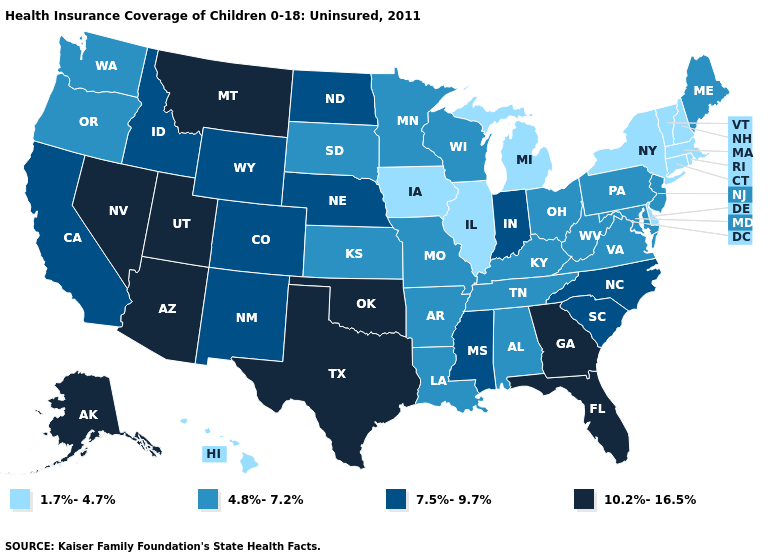Among the states that border Washington , which have the lowest value?
Write a very short answer. Oregon. Among the states that border Maryland , which have the lowest value?
Concise answer only. Delaware. How many symbols are there in the legend?
Give a very brief answer. 4. Does Texas have a higher value than Wisconsin?
Give a very brief answer. Yes. What is the value of South Carolina?
Concise answer only. 7.5%-9.7%. Among the states that border Minnesota , which have the highest value?
Quick response, please. North Dakota. What is the lowest value in the South?
Short answer required. 1.7%-4.7%. What is the lowest value in the MidWest?
Be succinct. 1.7%-4.7%. What is the highest value in the Northeast ?
Keep it brief. 4.8%-7.2%. Does the first symbol in the legend represent the smallest category?
Short answer required. Yes. Which states have the highest value in the USA?
Be succinct. Alaska, Arizona, Florida, Georgia, Montana, Nevada, Oklahoma, Texas, Utah. Does Colorado have the highest value in the West?
Answer briefly. No. How many symbols are there in the legend?
Answer briefly. 4. What is the highest value in states that border New Mexico?
Keep it brief. 10.2%-16.5%. Does Illinois have the lowest value in the USA?
Give a very brief answer. Yes. 